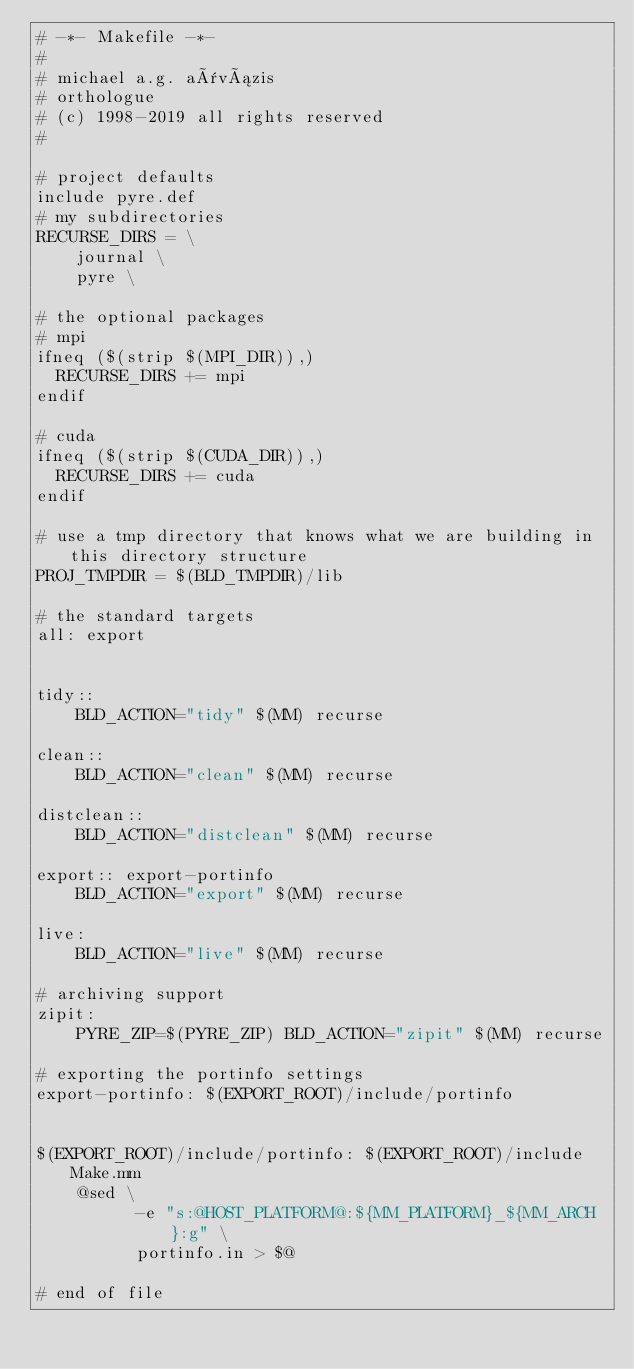Convert code to text. <code><loc_0><loc_0><loc_500><loc_500><_ObjectiveC_># -*- Makefile -*-
#
# michael a.g. aïvázis
# orthologue
# (c) 1998-2019 all rights reserved
#

# project defaults
include pyre.def
# my subdirectories
RECURSE_DIRS = \
    journal \
    pyre \

# the optional packages
# mpi
ifneq ($(strip $(MPI_DIR)),)
  RECURSE_DIRS += mpi
endif

# cuda
ifneq ($(strip $(CUDA_DIR)),)
  RECURSE_DIRS += cuda
endif

# use a tmp directory that knows what we are building in this directory structure
PROJ_TMPDIR = $(BLD_TMPDIR)/lib

# the standard targets
all: export


tidy::
	BLD_ACTION="tidy" $(MM) recurse

clean::
	BLD_ACTION="clean" $(MM) recurse

distclean::
	BLD_ACTION="distclean" $(MM) recurse

export:: export-portinfo
	BLD_ACTION="export" $(MM) recurse

live:
	BLD_ACTION="live" $(MM) recurse

# archiving support
zipit:
	PYRE_ZIP=$(PYRE_ZIP) BLD_ACTION="zipit" $(MM) recurse

# exporting the portinfo settings
export-portinfo: $(EXPORT_ROOT)/include/portinfo


$(EXPORT_ROOT)/include/portinfo: $(EXPORT_ROOT)/include Make.mm
	@sed \
          -e "s:@HOST_PLATFORM@:${MM_PLATFORM}_${MM_ARCH}:g" \
          portinfo.in > $@

# end of file
</code> 